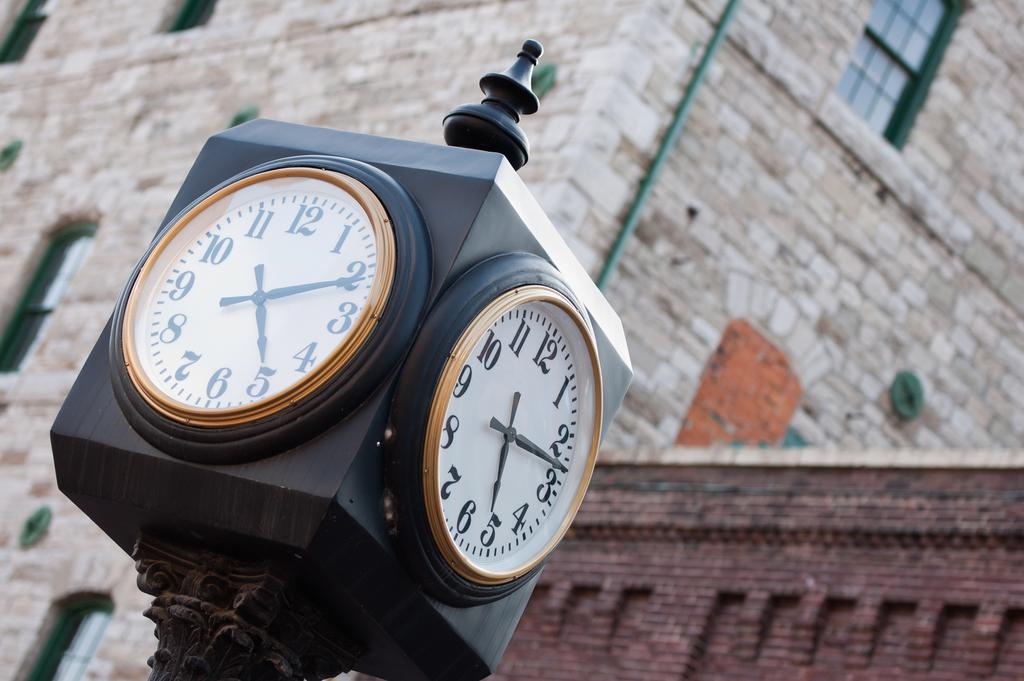<image>
Create a compact narrative representing the image presented. The black hands on the clock read 512 